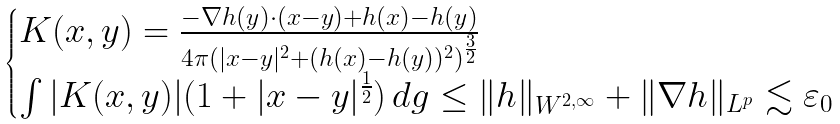Convert formula to latex. <formula><loc_0><loc_0><loc_500><loc_500>\begin{cases} K ( x , y ) = \frac { { - \nabla } h ( y ) \cdot ( x - y ) + h ( x ) - h ( y ) } { 4 \pi ( | x - y | ^ { 2 } + ( h ( x ) - h ( y ) ) ^ { 2 } ) ^ { \frac { 3 } { 2 } } } \\ \int | K ( x , y ) | ( 1 + | x - y | ^ { \frac { 1 } { 2 } } ) \, d g \leq \| h \| _ { W ^ { 2 , \infty } } + \| \nabla h \| _ { L ^ { p } } \lesssim \varepsilon _ { 0 } \end{cases}</formula> 